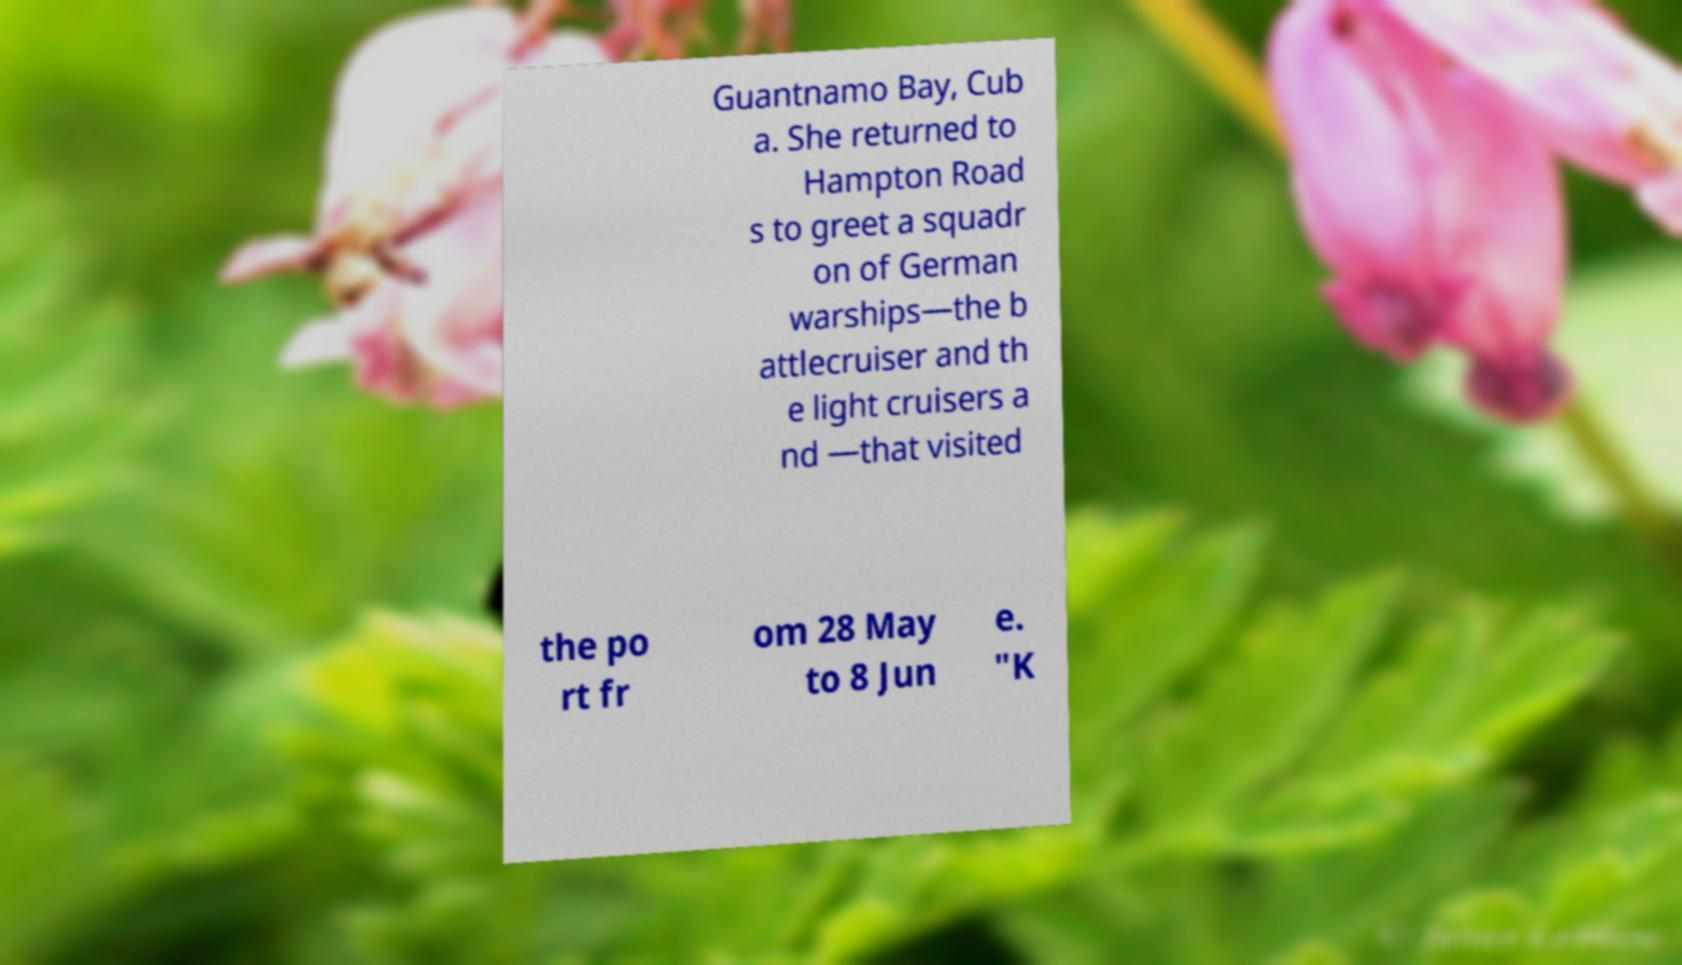What messages or text are displayed in this image? I need them in a readable, typed format. Guantnamo Bay, Cub a. She returned to Hampton Road s to greet a squadr on of German warships—the b attlecruiser and th e light cruisers a nd —that visited the po rt fr om 28 May to 8 Jun e. "K 